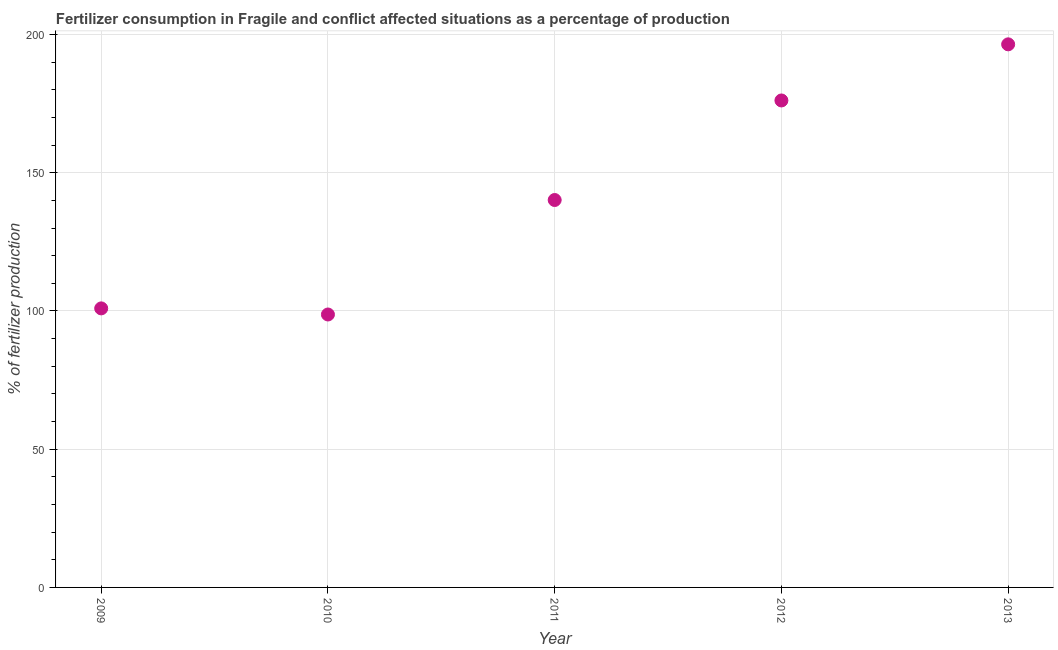What is the amount of fertilizer consumption in 2011?
Ensure brevity in your answer.  140.13. Across all years, what is the maximum amount of fertilizer consumption?
Provide a succinct answer. 196.44. Across all years, what is the minimum amount of fertilizer consumption?
Your response must be concise. 98.72. In which year was the amount of fertilizer consumption maximum?
Make the answer very short. 2013. What is the sum of the amount of fertilizer consumption?
Your response must be concise. 712.35. What is the difference between the amount of fertilizer consumption in 2012 and 2013?
Your response must be concise. -20.3. What is the average amount of fertilizer consumption per year?
Offer a very short reply. 142.47. What is the median amount of fertilizer consumption?
Keep it short and to the point. 140.13. In how many years, is the amount of fertilizer consumption greater than 80 %?
Your response must be concise. 5. Do a majority of the years between 2009 and 2013 (inclusive) have amount of fertilizer consumption greater than 90 %?
Give a very brief answer. Yes. What is the ratio of the amount of fertilizer consumption in 2010 to that in 2011?
Provide a short and direct response. 0.7. Is the difference between the amount of fertilizer consumption in 2011 and 2012 greater than the difference between any two years?
Ensure brevity in your answer.  No. What is the difference between the highest and the second highest amount of fertilizer consumption?
Give a very brief answer. 20.3. What is the difference between the highest and the lowest amount of fertilizer consumption?
Make the answer very short. 97.72. Does the amount of fertilizer consumption monotonically increase over the years?
Your answer should be compact. No. How many years are there in the graph?
Give a very brief answer. 5. Are the values on the major ticks of Y-axis written in scientific E-notation?
Provide a succinct answer. No. Does the graph contain any zero values?
Provide a succinct answer. No. Does the graph contain grids?
Provide a short and direct response. Yes. What is the title of the graph?
Offer a very short reply. Fertilizer consumption in Fragile and conflict affected situations as a percentage of production. What is the label or title of the X-axis?
Make the answer very short. Year. What is the label or title of the Y-axis?
Your response must be concise. % of fertilizer production. What is the % of fertilizer production in 2009?
Make the answer very short. 100.93. What is the % of fertilizer production in 2010?
Provide a succinct answer. 98.72. What is the % of fertilizer production in 2011?
Your answer should be compact. 140.13. What is the % of fertilizer production in 2012?
Offer a terse response. 176.14. What is the % of fertilizer production in 2013?
Your answer should be very brief. 196.44. What is the difference between the % of fertilizer production in 2009 and 2010?
Offer a terse response. 2.21. What is the difference between the % of fertilizer production in 2009 and 2011?
Provide a succinct answer. -39.2. What is the difference between the % of fertilizer production in 2009 and 2012?
Offer a very short reply. -75.21. What is the difference between the % of fertilizer production in 2009 and 2013?
Your answer should be compact. -95.51. What is the difference between the % of fertilizer production in 2010 and 2011?
Your response must be concise. -41.41. What is the difference between the % of fertilizer production in 2010 and 2012?
Offer a terse response. -77.42. What is the difference between the % of fertilizer production in 2010 and 2013?
Your response must be concise. -97.72. What is the difference between the % of fertilizer production in 2011 and 2012?
Make the answer very short. -36.01. What is the difference between the % of fertilizer production in 2011 and 2013?
Your answer should be very brief. -56.31. What is the difference between the % of fertilizer production in 2012 and 2013?
Make the answer very short. -20.3. What is the ratio of the % of fertilizer production in 2009 to that in 2011?
Provide a short and direct response. 0.72. What is the ratio of the % of fertilizer production in 2009 to that in 2012?
Keep it short and to the point. 0.57. What is the ratio of the % of fertilizer production in 2009 to that in 2013?
Make the answer very short. 0.51. What is the ratio of the % of fertilizer production in 2010 to that in 2011?
Give a very brief answer. 0.7. What is the ratio of the % of fertilizer production in 2010 to that in 2012?
Offer a very short reply. 0.56. What is the ratio of the % of fertilizer production in 2010 to that in 2013?
Your response must be concise. 0.5. What is the ratio of the % of fertilizer production in 2011 to that in 2012?
Offer a terse response. 0.8. What is the ratio of the % of fertilizer production in 2011 to that in 2013?
Offer a very short reply. 0.71. What is the ratio of the % of fertilizer production in 2012 to that in 2013?
Make the answer very short. 0.9. 